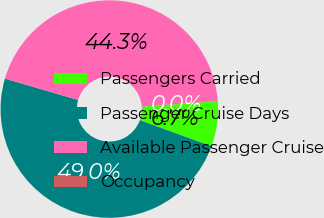Convert chart. <chart><loc_0><loc_0><loc_500><loc_500><pie_chart><fcel>Passengers Carried<fcel>Passenger Cruise Days<fcel>Available Passenger Cruise<fcel>Occupancy<nl><fcel>6.73%<fcel>48.95%<fcel>44.32%<fcel>0.0%<nl></chart> 